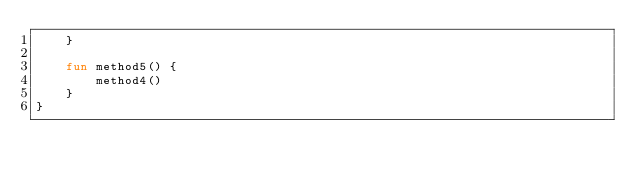<code> <loc_0><loc_0><loc_500><loc_500><_Kotlin_>    }

    fun method5() {
        method4()
    }
}
</code> 